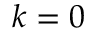Convert formula to latex. <formula><loc_0><loc_0><loc_500><loc_500>k = 0</formula> 